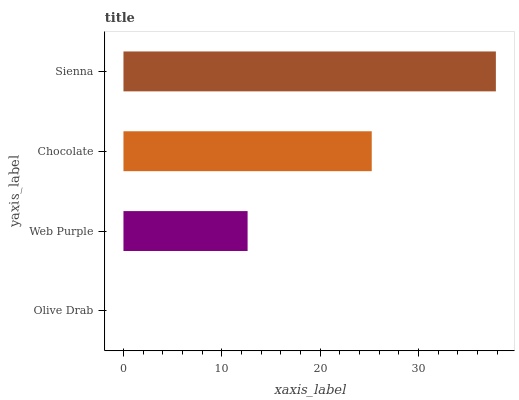Is Olive Drab the minimum?
Answer yes or no. Yes. Is Sienna the maximum?
Answer yes or no. Yes. Is Web Purple the minimum?
Answer yes or no. No. Is Web Purple the maximum?
Answer yes or no. No. Is Web Purple greater than Olive Drab?
Answer yes or no. Yes. Is Olive Drab less than Web Purple?
Answer yes or no. Yes. Is Olive Drab greater than Web Purple?
Answer yes or no. No. Is Web Purple less than Olive Drab?
Answer yes or no. No. Is Chocolate the high median?
Answer yes or no. Yes. Is Web Purple the low median?
Answer yes or no. Yes. Is Olive Drab the high median?
Answer yes or no. No. Is Olive Drab the low median?
Answer yes or no. No. 